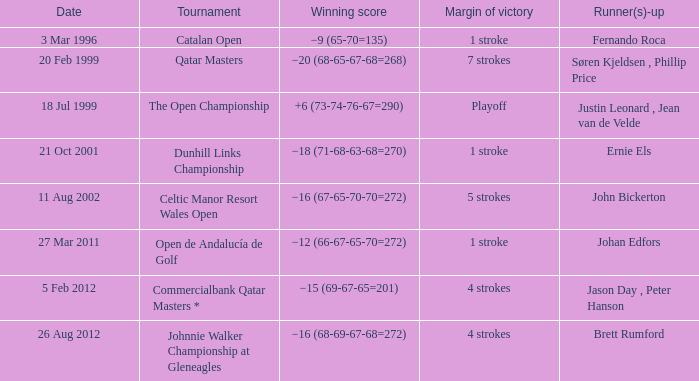What tournament that Fernando Roca is the runner-up? Catalan Open. 